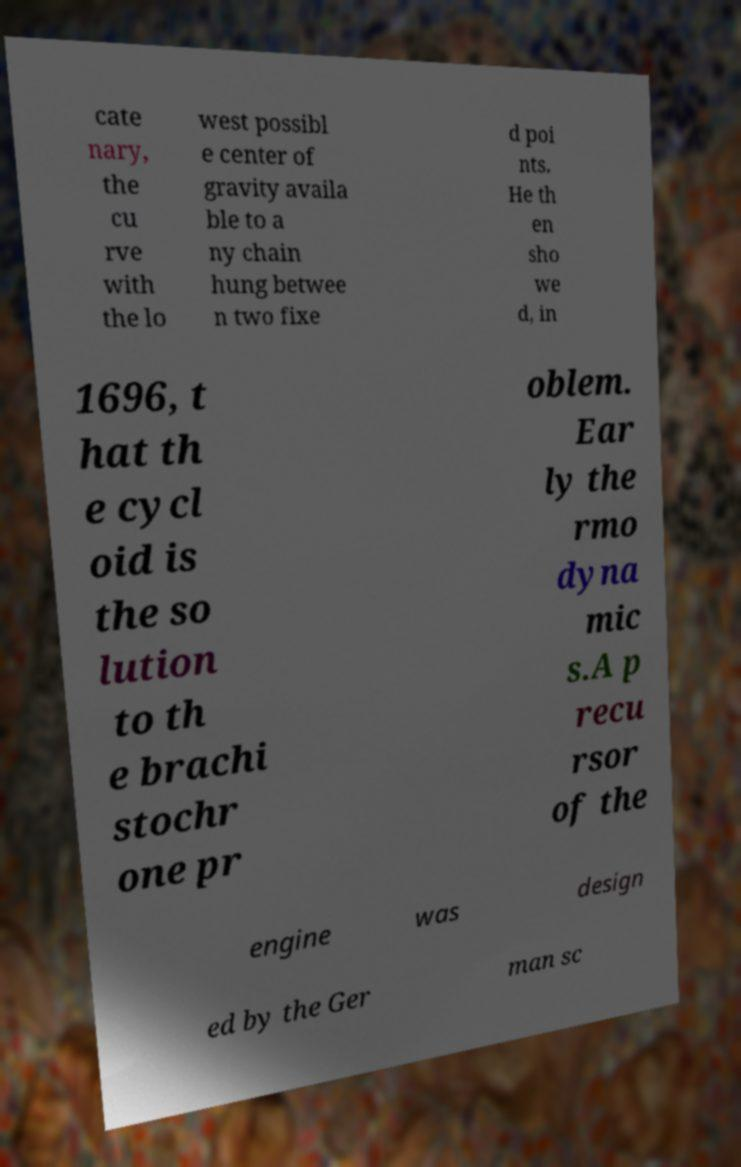I need the written content from this picture converted into text. Can you do that? cate nary, the cu rve with the lo west possibl e center of gravity availa ble to a ny chain hung betwee n two fixe d poi nts. He th en sho we d, in 1696, t hat th e cycl oid is the so lution to th e brachi stochr one pr oblem. Ear ly the rmo dyna mic s.A p recu rsor of the engine was design ed by the Ger man sc 